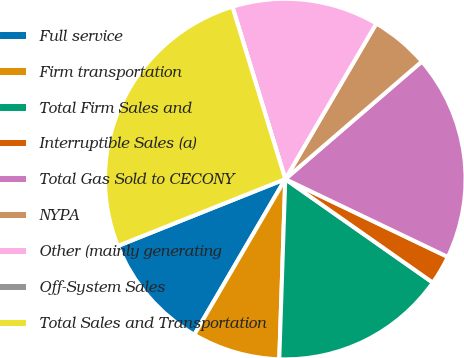Convert chart. <chart><loc_0><loc_0><loc_500><loc_500><pie_chart><fcel>Full service<fcel>Firm transportation<fcel>Total Firm Sales and<fcel>Interruptible Sales (a)<fcel>Total Gas Sold to CECONY<fcel>NYPA<fcel>Other (mainly generating<fcel>Off-System Sales<fcel>Total Sales and Transportation<nl><fcel>10.53%<fcel>7.89%<fcel>15.79%<fcel>2.63%<fcel>18.42%<fcel>5.26%<fcel>13.16%<fcel>0.0%<fcel>26.31%<nl></chart> 